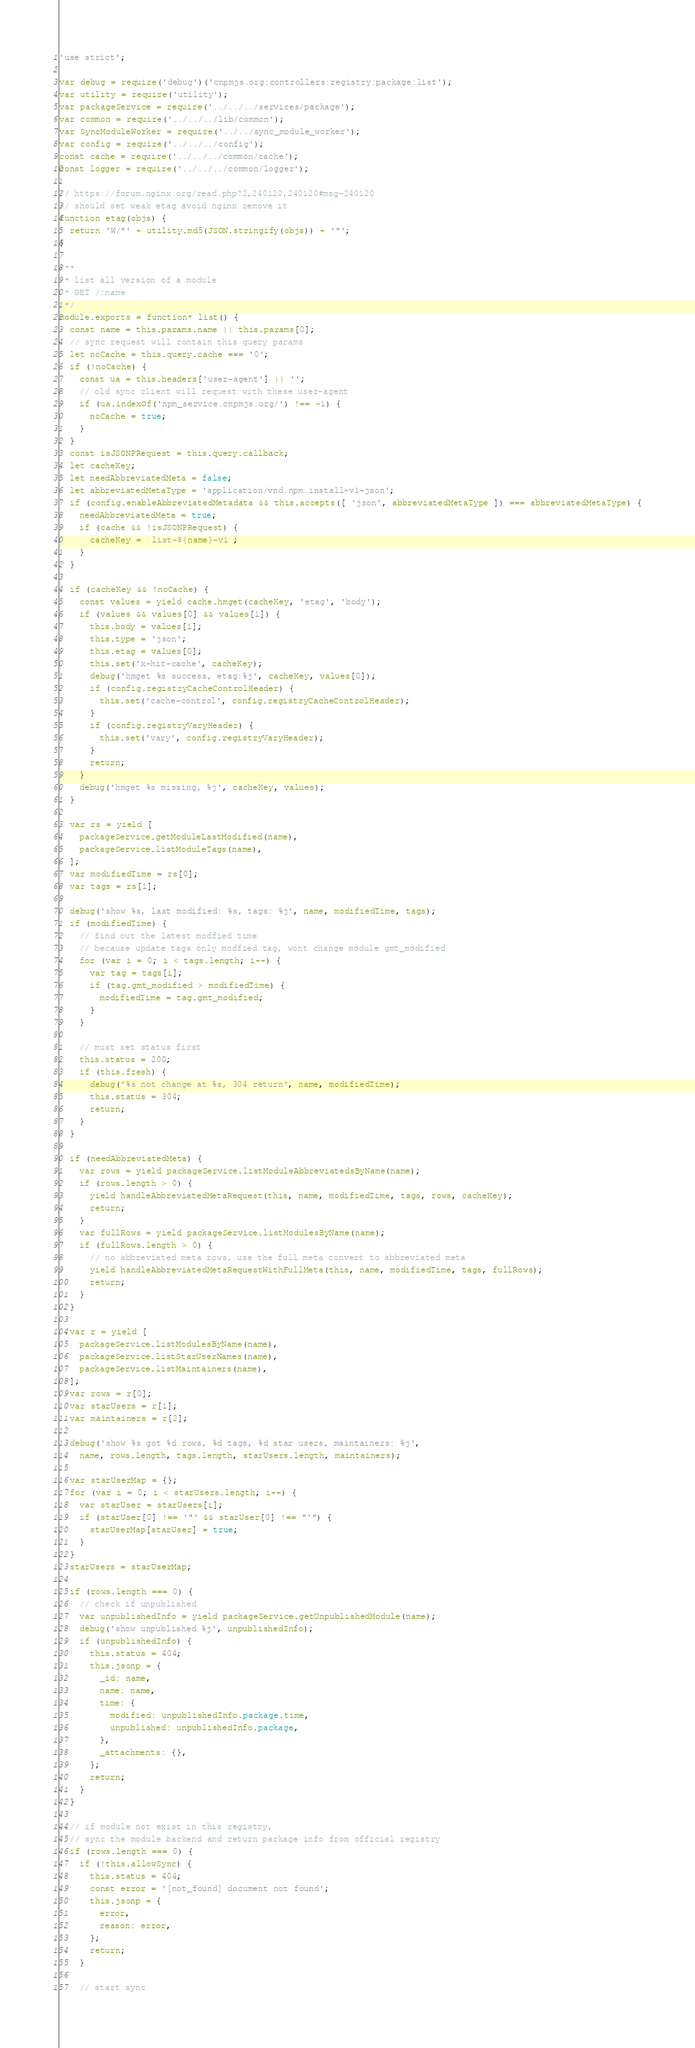Convert code to text. <code><loc_0><loc_0><loc_500><loc_500><_JavaScript_>'use strict';

var debug = require('debug')('cnpmjs.org:controllers:registry:package:list');
var utility = require('utility');
var packageService = require('../../../services/package');
var common = require('../../../lib/common');
var SyncModuleWorker = require('../../sync_module_worker');
var config = require('../../../config');
const cache = require('../../../common/cache');
const logger = require('../../../common/logger');

// https://forum.nginx.org/read.php?2,240120,240120#msg-240120
// should set weak etag avoid nginx remove it
function etag(objs) {
  return 'W/"' + utility.md5(JSON.stringify(objs)) + '"';
}

/**
 * list all version of a module
 * GET /:name
 */
module.exports = function* list() {
  const name = this.params.name || this.params[0];
  // sync request will contain this query params
  let noCache = this.query.cache === '0';
  if (!noCache) {
    const ua = this.headers['user-agent'] || '';
    // old sync client will request with these user-agent
    if (ua.indexOf('npm_service.cnpmjs.org/') !== -1) {
      noCache = true;
    }
  }
  const isJSONPRequest = this.query.callback;
  let cacheKey;
  let needAbbreviatedMeta = false;
  let abbreviatedMetaType = 'application/vnd.npm.install-v1+json';
  if (config.enableAbbreviatedMetadata && this.accepts([ 'json', abbreviatedMetaType ]) === abbreviatedMetaType) {
    needAbbreviatedMeta = true;
    if (cache && !isJSONPRequest) {
      cacheKey = `list-${name}-v1`;
    }
  }

  if (cacheKey && !noCache) {
    const values = yield cache.hmget(cacheKey, 'etag', 'body');
    if (values && values[0] && values[1]) {
      this.body = values[1];
      this.type = 'json';
      this.etag = values[0];
      this.set('x-hit-cache', cacheKey);
      debug('hmget %s success, etag:%j', cacheKey, values[0]);
      if (config.registryCacheControlHeader) {
        this.set('cache-control', config.registryCacheControlHeader);
      }
      if (config.registryVaryHeader) {
        this.set('vary', config.registryVaryHeader);
      }
      return;
    }
    debug('hmget %s missing, %j', cacheKey, values);
  }

  var rs = yield [
    packageService.getModuleLastModified(name),
    packageService.listModuleTags(name),
  ];
  var modifiedTime = rs[0];
  var tags = rs[1];

  debug('show %s, last modified: %s, tags: %j', name, modifiedTime, tags);
  if (modifiedTime) {
    // find out the latest modfied time
    // because update tags only modfied tag, wont change module gmt_modified
    for (var i = 0; i < tags.length; i++) {
      var tag = tags[i];
      if (tag.gmt_modified > modifiedTime) {
        modifiedTime = tag.gmt_modified;
      }
    }

    // must set status first
    this.status = 200;
    if (this.fresh) {
      debug('%s not change at %s, 304 return', name, modifiedTime);
      this.status = 304;
      return;
    }
  }

  if (needAbbreviatedMeta) {
    var rows = yield packageService.listModuleAbbreviatedsByName(name);
    if (rows.length > 0) {
      yield handleAbbreviatedMetaRequest(this, name, modifiedTime, tags, rows, cacheKey);
      return;
    }
    var fullRows = yield packageService.listModulesByName(name);
    if (fullRows.length > 0) {
      // no abbreviated meta rows, use the full meta convert to abbreviated meta
      yield handleAbbreviatedMetaRequestWithFullMeta(this, name, modifiedTime, tags, fullRows);
      return;
    }
  }

  var r = yield [
    packageService.listModulesByName(name),
    packageService.listStarUserNames(name),
    packageService.listMaintainers(name),
  ];
  var rows = r[0];
  var starUsers = r[1];
  var maintainers = r[2];

  debug('show %s got %d rows, %d tags, %d star users, maintainers: %j',
    name, rows.length, tags.length, starUsers.length, maintainers);

  var starUserMap = {};
  for (var i = 0; i < starUsers.length; i++) {
    var starUser = starUsers[i];
    if (starUser[0] !== '"' && starUser[0] !== "'") {
      starUserMap[starUser] = true;
    }
  }
  starUsers = starUserMap;

  if (rows.length === 0) {
    // check if unpublished
    var unpublishedInfo = yield packageService.getUnpublishedModule(name);
    debug('show unpublished %j', unpublishedInfo);
    if (unpublishedInfo) {
      this.status = 404;
      this.jsonp = {
        _id: name,
        name: name,
        time: {
          modified: unpublishedInfo.package.time,
          unpublished: unpublishedInfo.package,
        },
        _attachments: {},
      };
      return;
    }
  }

  // if module not exist in this registry,
  // sync the module backend and return package info from official registry
  if (rows.length === 0) {
    if (!this.allowSync) {
      this.status = 404;
      const error = '[not_found] document not found';
      this.jsonp = {
        error,
        reason: error,
      };
      return;
    }

    // start sync</code> 